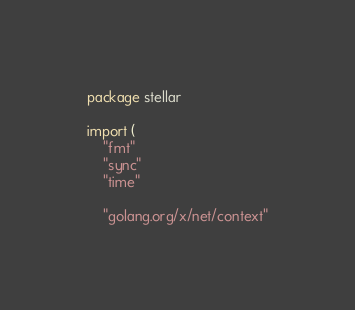Convert code to text. <code><loc_0><loc_0><loc_500><loc_500><_Go_>package stellar

import (
	"fmt"
	"sync"
	"time"

	"golang.org/x/net/context"
</code> 